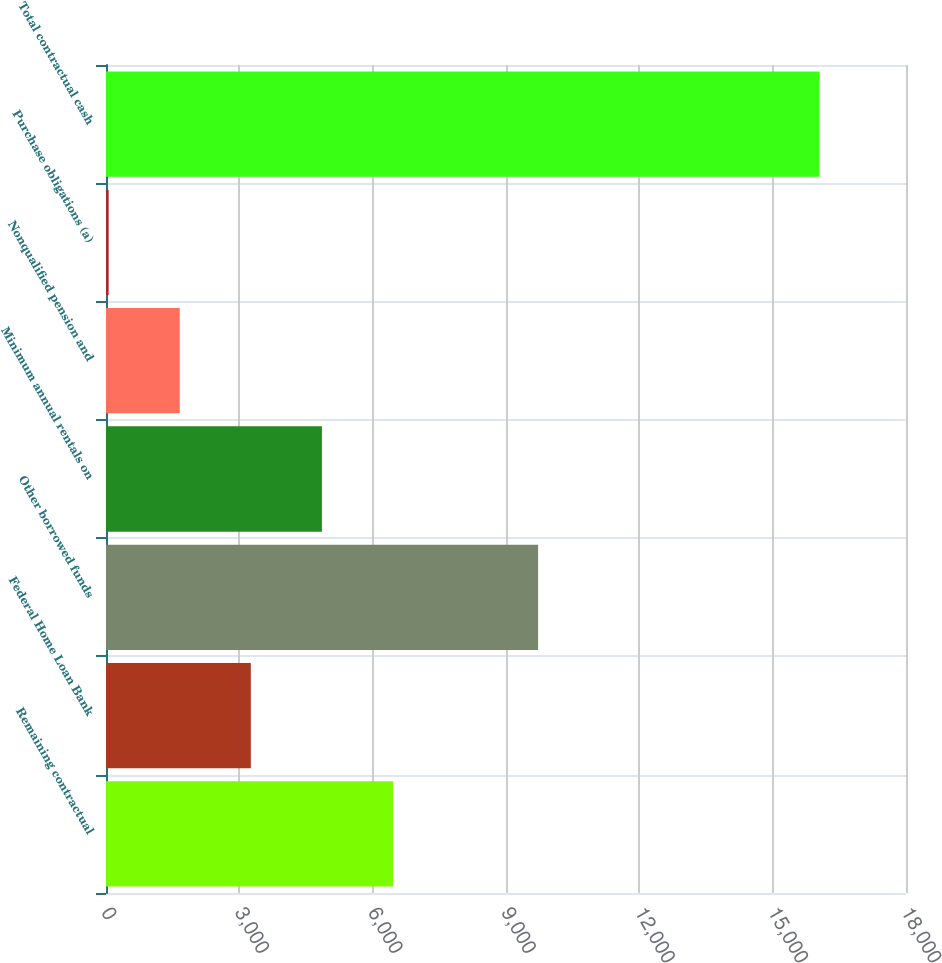<chart> <loc_0><loc_0><loc_500><loc_500><bar_chart><fcel>Remaining contractual<fcel>Federal Home Loan Bank<fcel>Other borrowed funds<fcel>Minimum annual rentals on<fcel>Nonqualified pension and<fcel>Purchase obligations (a)<fcel>Total contractual cash<nl><fcel>6457.6<fcel>3258.8<fcel>9722<fcel>4858.2<fcel>1659.4<fcel>60<fcel>16054<nl></chart> 